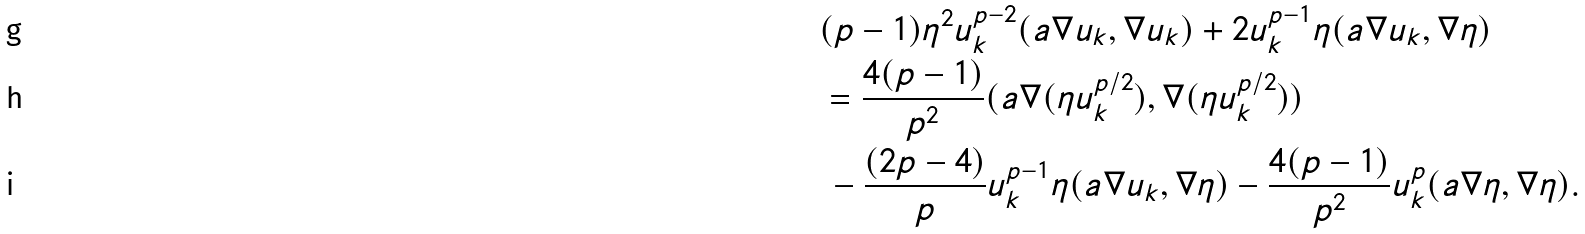Convert formula to latex. <formula><loc_0><loc_0><loc_500><loc_500>& ( p - 1 ) \eta ^ { 2 } u _ { k } ^ { p - 2 } ( a \nabla u _ { k } , \nabla u _ { k } ) + 2 u _ { k } ^ { p - 1 } \eta ( a \nabla u _ { k } , \nabla \eta ) \\ & = \frac { 4 ( p - 1 ) } { p ^ { 2 } } ( a \nabla ( \eta u _ { k } ^ { p / 2 } ) , \nabla ( \eta u _ { k } ^ { p / 2 } ) ) \\ & \, - \frac { ( 2 p - 4 ) } { p } u _ { k } ^ { p - 1 } \eta ( a \nabla u _ { k } , \nabla \eta ) - \frac { 4 ( p - 1 ) } { p ^ { 2 } } u _ { k } ^ { p } ( a \nabla \eta , \nabla \eta ) .</formula> 